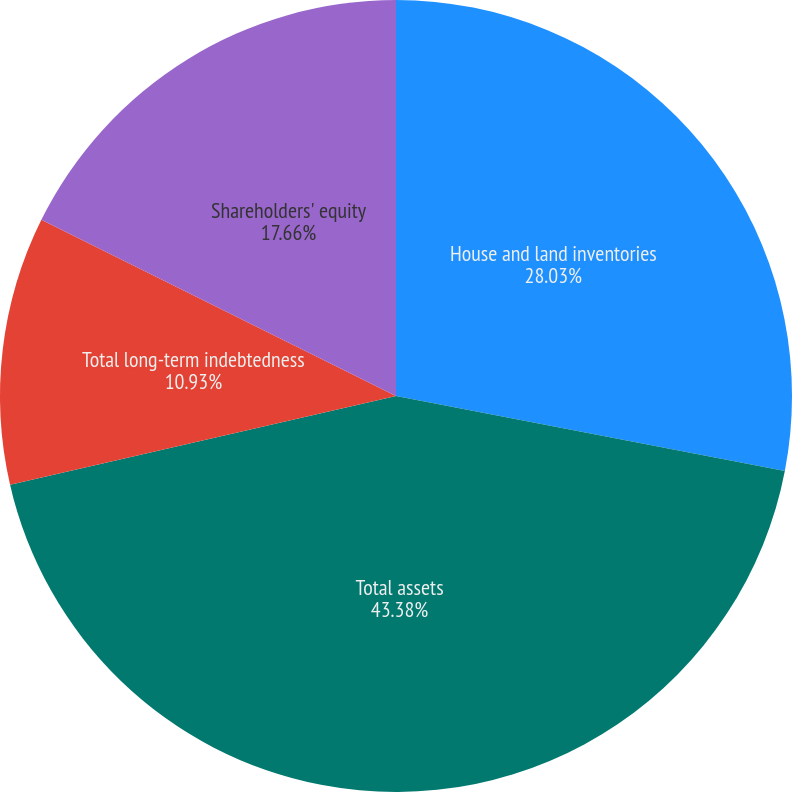<chart> <loc_0><loc_0><loc_500><loc_500><pie_chart><fcel>House and land inventories<fcel>Total assets<fcel>Total long-term indebtedness<fcel>Shareholders' equity<nl><fcel>28.03%<fcel>43.37%<fcel>10.93%<fcel>17.66%<nl></chart> 